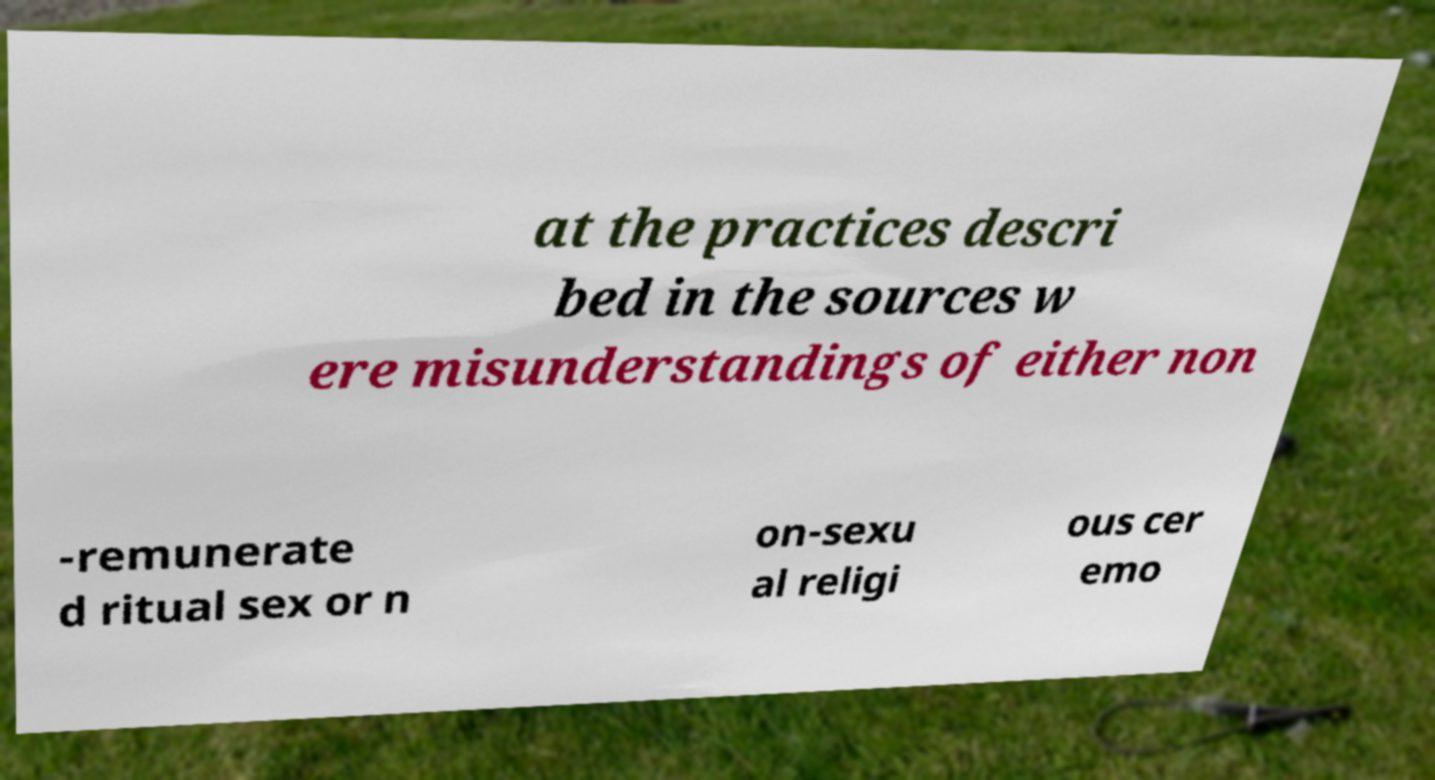Could you assist in decoding the text presented in this image and type it out clearly? at the practices descri bed in the sources w ere misunderstandings of either non -remunerate d ritual sex or n on-sexu al religi ous cer emo 